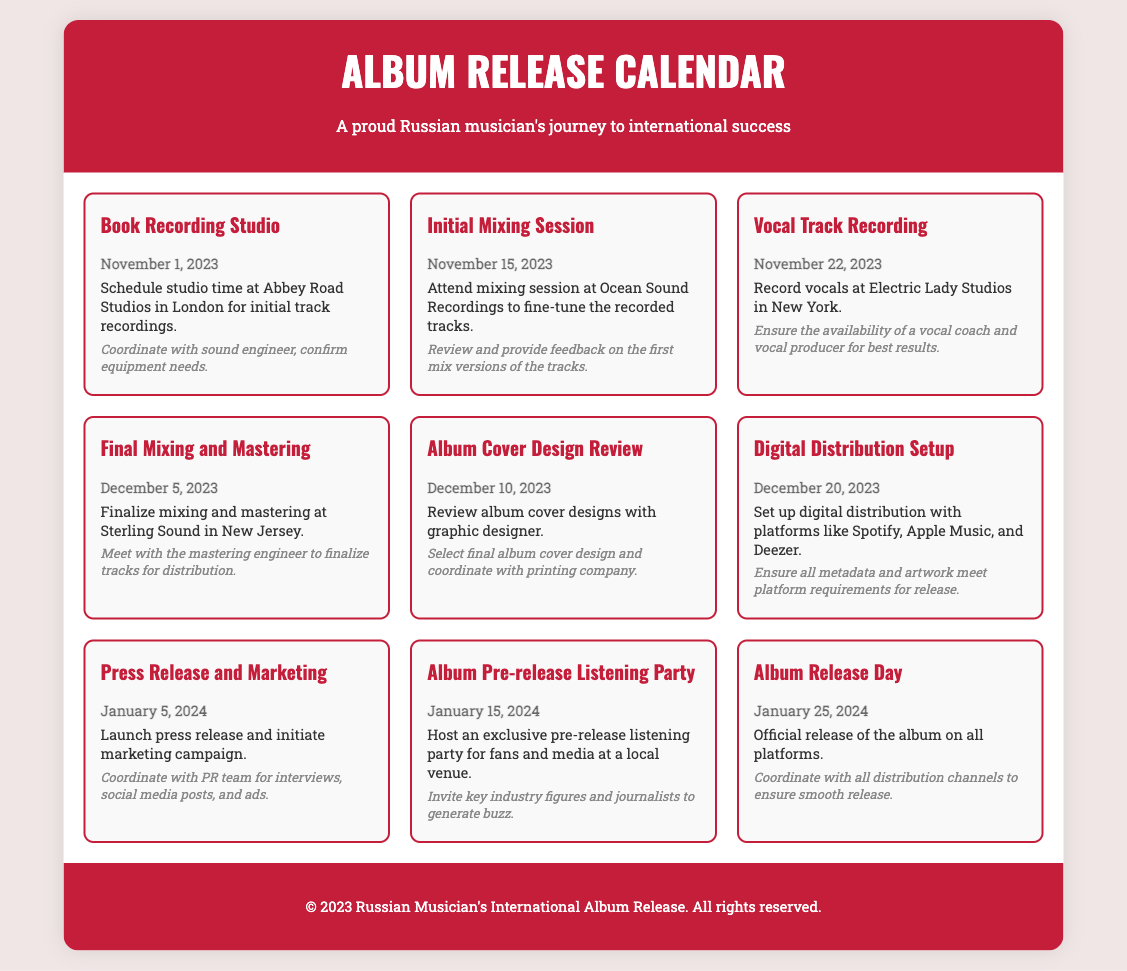What is the first event scheduled? The first event in the calendar is “Book Recording Studio” on November 1, 2023.
Answer: Book Recording Studio When is the vocal track recording scheduled? The vocal track recording is scheduled for November 22, 2023.
Answer: November 22, 2023 What studio will the final mixing and mastering take place? The final mixing and mastering will occur at Sterling Sound in New Jersey.
Answer: Sterling Sound How many days before the album release is the pre-release listening party? The pre-release listening party is 10 days before the album release day on January 25, 2024.
Answer: 10 days What is the purpose of the digital distribution setup? The purpose is to set up digital distribution with platforms like Spotify, Apple Music, and Deezer.
Answer: Digital distribution setup Which event involves reviewing album cover designs? The event that involves reviewing album cover designs is “Album Cover Design Review.”
Answer: Album Cover Design Review 